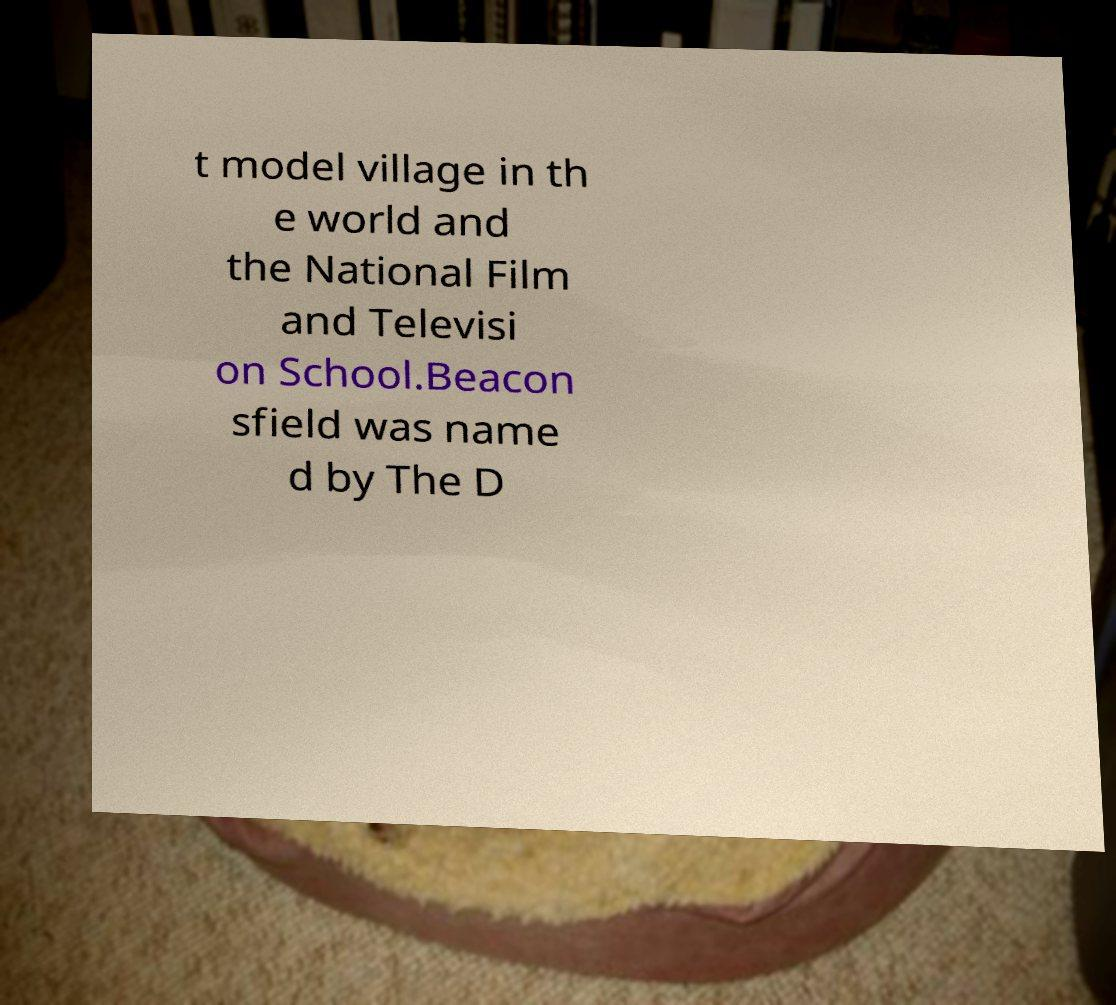Can you accurately transcribe the text from the provided image for me? t model village in th e world and the National Film and Televisi on School.Beacon sfield was name d by The D 